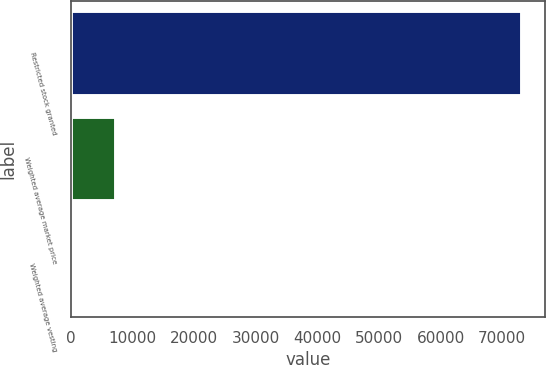Convert chart to OTSL. <chart><loc_0><loc_0><loc_500><loc_500><bar_chart><fcel>Restricted stock granted<fcel>Weighted average market price<fcel>Weighted average vesting<nl><fcel>73255<fcel>7329.48<fcel>4.42<nl></chart> 